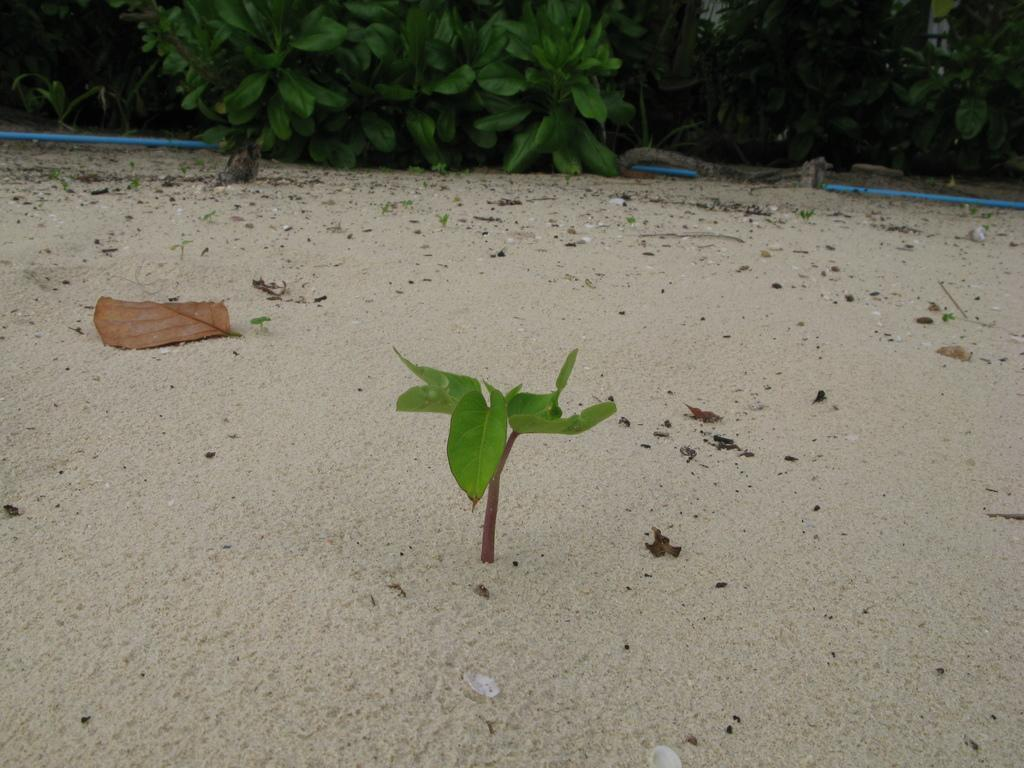What type of plant can be seen in the image? There is a baby plant in the image. What is the texture of the ground in the image? Sand is present in the image. What type of leaves can be seen in the image? Dry leaves and green leaves are visible in the image. What color is the pipe in the image? There is a blue pipe in the image. What type of verse is being recited by the toothpaste in the image? There is no toothpaste present in the image, and therefore no verse being recited. 